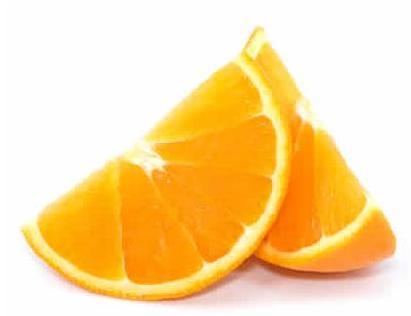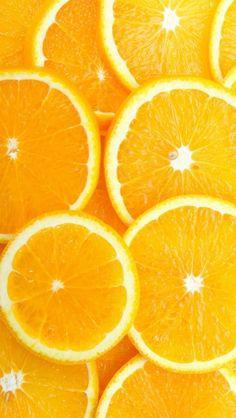The first image is the image on the left, the second image is the image on the right. For the images shown, is this caption "There is fruit on a white surface." true? Answer yes or no. Yes. The first image is the image on the left, the second image is the image on the right. Considering the images on both sides, is "In one image, the oranges are quartered and in the other they are sliced circles." valid? Answer yes or no. Yes. 